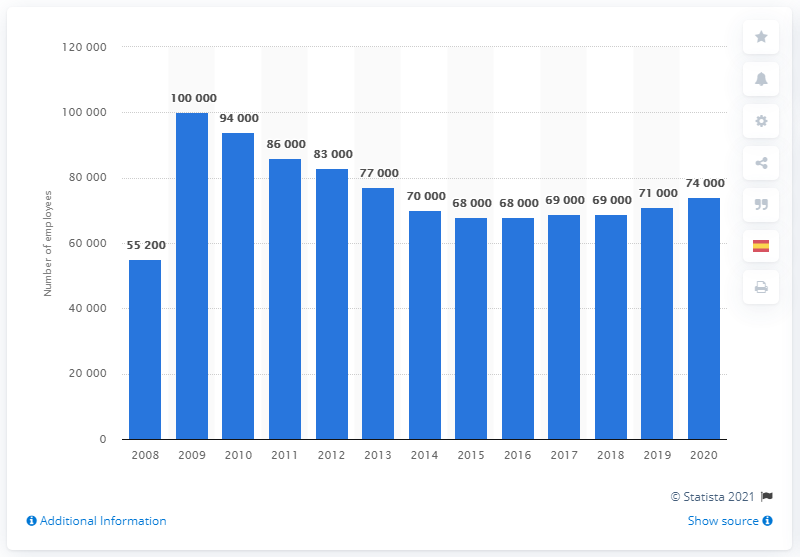In what year did Merck & Co. have the largest number of employees?
 2009 